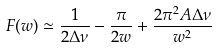Convert formula to latex. <formula><loc_0><loc_0><loc_500><loc_500>F ( w ) \simeq \frac { 1 } { 2 \Delta \nu } - \frac { \pi } { 2 w } + \frac { 2 \pi ^ { 2 } A \Delta \nu } { w ^ { 2 } }</formula> 